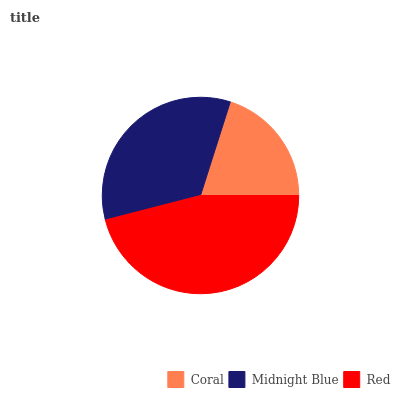Is Coral the minimum?
Answer yes or no. Yes. Is Red the maximum?
Answer yes or no. Yes. Is Midnight Blue the minimum?
Answer yes or no. No. Is Midnight Blue the maximum?
Answer yes or no. No. Is Midnight Blue greater than Coral?
Answer yes or no. Yes. Is Coral less than Midnight Blue?
Answer yes or no. Yes. Is Coral greater than Midnight Blue?
Answer yes or no. No. Is Midnight Blue less than Coral?
Answer yes or no. No. Is Midnight Blue the high median?
Answer yes or no. Yes. Is Midnight Blue the low median?
Answer yes or no. Yes. Is Coral the high median?
Answer yes or no. No. Is Coral the low median?
Answer yes or no. No. 